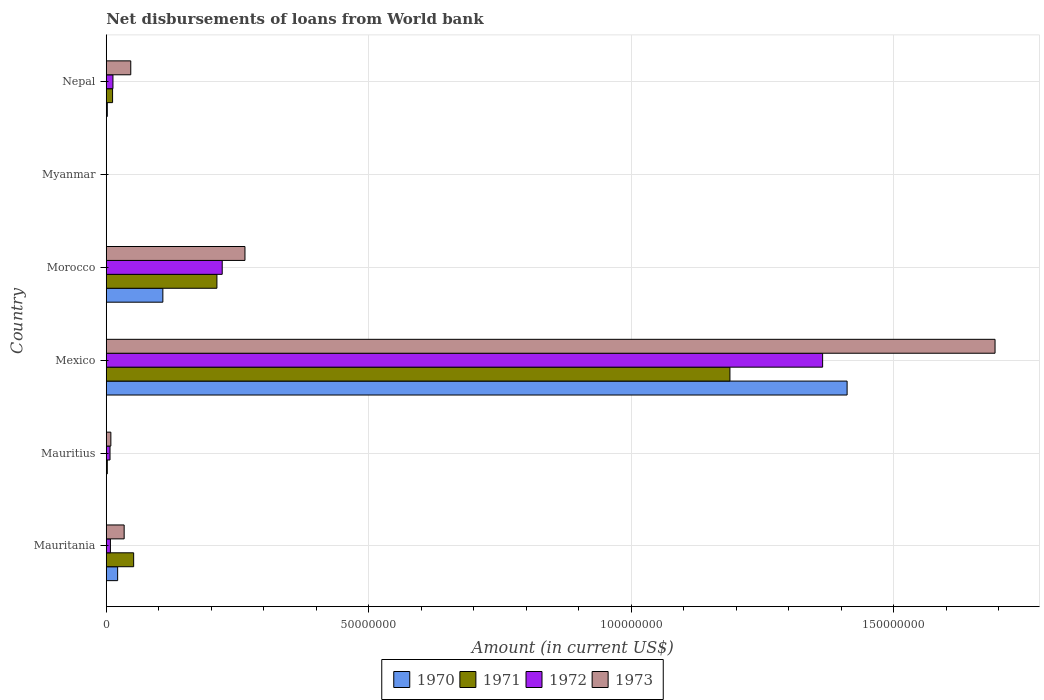Are the number of bars on each tick of the Y-axis equal?
Give a very brief answer. No. How many bars are there on the 4th tick from the top?
Provide a short and direct response. 4. How many bars are there on the 6th tick from the bottom?
Offer a terse response. 4. What is the label of the 4th group of bars from the top?
Offer a terse response. Mexico. What is the amount of loan disbursed from World Bank in 1972 in Myanmar?
Make the answer very short. 0. Across all countries, what is the maximum amount of loan disbursed from World Bank in 1972?
Keep it short and to the point. 1.36e+08. What is the total amount of loan disbursed from World Bank in 1970 in the graph?
Provide a succinct answer. 1.54e+08. What is the difference between the amount of loan disbursed from World Bank in 1970 in Mexico and that in Nepal?
Your answer should be very brief. 1.41e+08. What is the difference between the amount of loan disbursed from World Bank in 1972 in Morocco and the amount of loan disbursed from World Bank in 1970 in Nepal?
Ensure brevity in your answer.  2.19e+07. What is the average amount of loan disbursed from World Bank in 1972 per country?
Provide a succinct answer. 2.69e+07. What is the difference between the amount of loan disbursed from World Bank in 1972 and amount of loan disbursed from World Bank in 1970 in Morocco?
Offer a very short reply. 1.13e+07. What is the ratio of the amount of loan disbursed from World Bank in 1973 in Morocco to that in Nepal?
Offer a terse response. 5.66. Is the amount of loan disbursed from World Bank in 1971 in Mauritius less than that in Morocco?
Make the answer very short. Yes. What is the difference between the highest and the second highest amount of loan disbursed from World Bank in 1971?
Offer a very short reply. 9.77e+07. What is the difference between the highest and the lowest amount of loan disbursed from World Bank in 1973?
Your response must be concise. 1.69e+08. Is it the case that in every country, the sum of the amount of loan disbursed from World Bank in 1970 and amount of loan disbursed from World Bank in 1972 is greater than the amount of loan disbursed from World Bank in 1971?
Give a very brief answer. No. What is the difference between two consecutive major ticks on the X-axis?
Keep it short and to the point. 5.00e+07. Where does the legend appear in the graph?
Offer a very short reply. Bottom center. How many legend labels are there?
Offer a terse response. 4. How are the legend labels stacked?
Make the answer very short. Horizontal. What is the title of the graph?
Provide a succinct answer. Net disbursements of loans from World bank. Does "1991" appear as one of the legend labels in the graph?
Give a very brief answer. No. What is the label or title of the X-axis?
Ensure brevity in your answer.  Amount (in current US$). What is the Amount (in current US$) in 1970 in Mauritania?
Your answer should be compact. 2.17e+06. What is the Amount (in current US$) in 1971 in Mauritania?
Give a very brief answer. 5.22e+06. What is the Amount (in current US$) of 1972 in Mauritania?
Ensure brevity in your answer.  7.93e+05. What is the Amount (in current US$) of 1973 in Mauritania?
Ensure brevity in your answer.  3.41e+06. What is the Amount (in current US$) of 1970 in Mauritius?
Your answer should be very brief. 0. What is the Amount (in current US$) in 1971 in Mauritius?
Provide a short and direct response. 1.99e+05. What is the Amount (in current US$) of 1972 in Mauritius?
Your answer should be compact. 7.17e+05. What is the Amount (in current US$) in 1973 in Mauritius?
Provide a succinct answer. 8.79e+05. What is the Amount (in current US$) in 1970 in Mexico?
Provide a succinct answer. 1.41e+08. What is the Amount (in current US$) in 1971 in Mexico?
Keep it short and to the point. 1.19e+08. What is the Amount (in current US$) in 1972 in Mexico?
Your answer should be very brief. 1.36e+08. What is the Amount (in current US$) of 1973 in Mexico?
Offer a terse response. 1.69e+08. What is the Amount (in current US$) in 1970 in Morocco?
Your response must be concise. 1.08e+07. What is the Amount (in current US$) of 1971 in Morocco?
Give a very brief answer. 2.11e+07. What is the Amount (in current US$) of 1972 in Morocco?
Provide a short and direct response. 2.21e+07. What is the Amount (in current US$) in 1973 in Morocco?
Your answer should be compact. 2.64e+07. What is the Amount (in current US$) of 1970 in Myanmar?
Give a very brief answer. 0. What is the Amount (in current US$) in 1971 in Myanmar?
Keep it short and to the point. 0. What is the Amount (in current US$) of 1972 in Myanmar?
Keep it short and to the point. 0. What is the Amount (in current US$) in 1970 in Nepal?
Provide a succinct answer. 2.02e+05. What is the Amount (in current US$) in 1971 in Nepal?
Ensure brevity in your answer.  1.21e+06. What is the Amount (in current US$) of 1972 in Nepal?
Your answer should be compact. 1.28e+06. What is the Amount (in current US$) in 1973 in Nepal?
Your answer should be very brief. 4.67e+06. Across all countries, what is the maximum Amount (in current US$) of 1970?
Make the answer very short. 1.41e+08. Across all countries, what is the maximum Amount (in current US$) of 1971?
Give a very brief answer. 1.19e+08. Across all countries, what is the maximum Amount (in current US$) in 1972?
Your answer should be compact. 1.36e+08. Across all countries, what is the maximum Amount (in current US$) in 1973?
Give a very brief answer. 1.69e+08. Across all countries, what is the minimum Amount (in current US$) in 1971?
Your answer should be compact. 0. Across all countries, what is the minimum Amount (in current US$) in 1972?
Your answer should be very brief. 0. Across all countries, what is the minimum Amount (in current US$) of 1973?
Offer a very short reply. 0. What is the total Amount (in current US$) of 1970 in the graph?
Make the answer very short. 1.54e+08. What is the total Amount (in current US$) of 1971 in the graph?
Your response must be concise. 1.46e+08. What is the total Amount (in current US$) of 1972 in the graph?
Keep it short and to the point. 1.61e+08. What is the total Amount (in current US$) of 1973 in the graph?
Give a very brief answer. 2.05e+08. What is the difference between the Amount (in current US$) of 1971 in Mauritania and that in Mauritius?
Your answer should be compact. 5.02e+06. What is the difference between the Amount (in current US$) of 1972 in Mauritania and that in Mauritius?
Ensure brevity in your answer.  7.60e+04. What is the difference between the Amount (in current US$) in 1973 in Mauritania and that in Mauritius?
Provide a succinct answer. 2.53e+06. What is the difference between the Amount (in current US$) of 1970 in Mauritania and that in Mexico?
Your answer should be very brief. -1.39e+08. What is the difference between the Amount (in current US$) in 1971 in Mauritania and that in Mexico?
Provide a succinct answer. -1.14e+08. What is the difference between the Amount (in current US$) of 1972 in Mauritania and that in Mexico?
Make the answer very short. -1.36e+08. What is the difference between the Amount (in current US$) of 1973 in Mauritania and that in Mexico?
Provide a succinct answer. -1.66e+08. What is the difference between the Amount (in current US$) of 1970 in Mauritania and that in Morocco?
Keep it short and to the point. -8.61e+06. What is the difference between the Amount (in current US$) of 1971 in Mauritania and that in Morocco?
Provide a short and direct response. -1.59e+07. What is the difference between the Amount (in current US$) in 1972 in Mauritania and that in Morocco?
Your answer should be compact. -2.13e+07. What is the difference between the Amount (in current US$) in 1973 in Mauritania and that in Morocco?
Ensure brevity in your answer.  -2.30e+07. What is the difference between the Amount (in current US$) of 1970 in Mauritania and that in Nepal?
Make the answer very short. 1.97e+06. What is the difference between the Amount (in current US$) of 1971 in Mauritania and that in Nepal?
Offer a terse response. 4.01e+06. What is the difference between the Amount (in current US$) in 1972 in Mauritania and that in Nepal?
Keep it short and to the point. -4.84e+05. What is the difference between the Amount (in current US$) in 1973 in Mauritania and that in Nepal?
Offer a very short reply. -1.26e+06. What is the difference between the Amount (in current US$) of 1971 in Mauritius and that in Mexico?
Offer a terse response. -1.19e+08. What is the difference between the Amount (in current US$) in 1972 in Mauritius and that in Mexico?
Ensure brevity in your answer.  -1.36e+08. What is the difference between the Amount (in current US$) in 1973 in Mauritius and that in Mexico?
Provide a short and direct response. -1.68e+08. What is the difference between the Amount (in current US$) in 1971 in Mauritius and that in Morocco?
Ensure brevity in your answer.  -2.09e+07. What is the difference between the Amount (in current US$) in 1972 in Mauritius and that in Morocco?
Your answer should be very brief. -2.14e+07. What is the difference between the Amount (in current US$) in 1973 in Mauritius and that in Morocco?
Your response must be concise. -2.55e+07. What is the difference between the Amount (in current US$) in 1971 in Mauritius and that in Nepal?
Offer a very short reply. -1.01e+06. What is the difference between the Amount (in current US$) of 1972 in Mauritius and that in Nepal?
Ensure brevity in your answer.  -5.60e+05. What is the difference between the Amount (in current US$) in 1973 in Mauritius and that in Nepal?
Keep it short and to the point. -3.79e+06. What is the difference between the Amount (in current US$) of 1970 in Mexico and that in Morocco?
Your answer should be compact. 1.30e+08. What is the difference between the Amount (in current US$) in 1971 in Mexico and that in Morocco?
Give a very brief answer. 9.77e+07. What is the difference between the Amount (in current US$) of 1972 in Mexico and that in Morocco?
Your response must be concise. 1.14e+08. What is the difference between the Amount (in current US$) of 1973 in Mexico and that in Morocco?
Make the answer very short. 1.43e+08. What is the difference between the Amount (in current US$) of 1970 in Mexico and that in Nepal?
Provide a succinct answer. 1.41e+08. What is the difference between the Amount (in current US$) of 1971 in Mexico and that in Nepal?
Offer a terse response. 1.18e+08. What is the difference between the Amount (in current US$) of 1972 in Mexico and that in Nepal?
Keep it short and to the point. 1.35e+08. What is the difference between the Amount (in current US$) in 1973 in Mexico and that in Nepal?
Ensure brevity in your answer.  1.65e+08. What is the difference between the Amount (in current US$) in 1970 in Morocco and that in Nepal?
Offer a very short reply. 1.06e+07. What is the difference between the Amount (in current US$) of 1971 in Morocco and that in Nepal?
Offer a terse response. 1.99e+07. What is the difference between the Amount (in current US$) in 1972 in Morocco and that in Nepal?
Your answer should be very brief. 2.08e+07. What is the difference between the Amount (in current US$) in 1973 in Morocco and that in Nepal?
Provide a succinct answer. 2.18e+07. What is the difference between the Amount (in current US$) of 1970 in Mauritania and the Amount (in current US$) of 1971 in Mauritius?
Provide a short and direct response. 1.97e+06. What is the difference between the Amount (in current US$) of 1970 in Mauritania and the Amount (in current US$) of 1972 in Mauritius?
Offer a terse response. 1.45e+06. What is the difference between the Amount (in current US$) of 1970 in Mauritania and the Amount (in current US$) of 1973 in Mauritius?
Your response must be concise. 1.29e+06. What is the difference between the Amount (in current US$) of 1971 in Mauritania and the Amount (in current US$) of 1972 in Mauritius?
Your answer should be very brief. 4.50e+06. What is the difference between the Amount (in current US$) of 1971 in Mauritania and the Amount (in current US$) of 1973 in Mauritius?
Offer a terse response. 4.34e+06. What is the difference between the Amount (in current US$) in 1972 in Mauritania and the Amount (in current US$) in 1973 in Mauritius?
Keep it short and to the point. -8.60e+04. What is the difference between the Amount (in current US$) in 1970 in Mauritania and the Amount (in current US$) in 1971 in Mexico?
Provide a short and direct response. -1.17e+08. What is the difference between the Amount (in current US$) in 1970 in Mauritania and the Amount (in current US$) in 1972 in Mexico?
Provide a short and direct response. -1.34e+08. What is the difference between the Amount (in current US$) in 1970 in Mauritania and the Amount (in current US$) in 1973 in Mexico?
Ensure brevity in your answer.  -1.67e+08. What is the difference between the Amount (in current US$) in 1971 in Mauritania and the Amount (in current US$) in 1972 in Mexico?
Provide a short and direct response. -1.31e+08. What is the difference between the Amount (in current US$) in 1971 in Mauritania and the Amount (in current US$) in 1973 in Mexico?
Your answer should be compact. -1.64e+08. What is the difference between the Amount (in current US$) in 1972 in Mauritania and the Amount (in current US$) in 1973 in Mexico?
Your answer should be very brief. -1.68e+08. What is the difference between the Amount (in current US$) in 1970 in Mauritania and the Amount (in current US$) in 1971 in Morocco?
Ensure brevity in your answer.  -1.89e+07. What is the difference between the Amount (in current US$) in 1970 in Mauritania and the Amount (in current US$) in 1972 in Morocco?
Keep it short and to the point. -1.99e+07. What is the difference between the Amount (in current US$) in 1970 in Mauritania and the Amount (in current US$) in 1973 in Morocco?
Give a very brief answer. -2.43e+07. What is the difference between the Amount (in current US$) of 1971 in Mauritania and the Amount (in current US$) of 1972 in Morocco?
Provide a succinct answer. -1.69e+07. What is the difference between the Amount (in current US$) of 1971 in Mauritania and the Amount (in current US$) of 1973 in Morocco?
Offer a terse response. -2.12e+07. What is the difference between the Amount (in current US$) of 1972 in Mauritania and the Amount (in current US$) of 1973 in Morocco?
Ensure brevity in your answer.  -2.56e+07. What is the difference between the Amount (in current US$) of 1970 in Mauritania and the Amount (in current US$) of 1971 in Nepal?
Give a very brief answer. 9.63e+05. What is the difference between the Amount (in current US$) of 1970 in Mauritania and the Amount (in current US$) of 1972 in Nepal?
Keep it short and to the point. 8.93e+05. What is the difference between the Amount (in current US$) in 1970 in Mauritania and the Amount (in current US$) in 1973 in Nepal?
Provide a succinct answer. -2.50e+06. What is the difference between the Amount (in current US$) in 1971 in Mauritania and the Amount (in current US$) in 1972 in Nepal?
Provide a short and direct response. 3.94e+06. What is the difference between the Amount (in current US$) in 1971 in Mauritania and the Amount (in current US$) in 1973 in Nepal?
Provide a succinct answer. 5.52e+05. What is the difference between the Amount (in current US$) in 1972 in Mauritania and the Amount (in current US$) in 1973 in Nepal?
Your response must be concise. -3.88e+06. What is the difference between the Amount (in current US$) of 1971 in Mauritius and the Amount (in current US$) of 1972 in Mexico?
Your answer should be very brief. -1.36e+08. What is the difference between the Amount (in current US$) in 1971 in Mauritius and the Amount (in current US$) in 1973 in Mexico?
Your response must be concise. -1.69e+08. What is the difference between the Amount (in current US$) of 1972 in Mauritius and the Amount (in current US$) of 1973 in Mexico?
Offer a terse response. -1.69e+08. What is the difference between the Amount (in current US$) in 1971 in Mauritius and the Amount (in current US$) in 1972 in Morocco?
Provide a short and direct response. -2.19e+07. What is the difference between the Amount (in current US$) of 1971 in Mauritius and the Amount (in current US$) of 1973 in Morocco?
Give a very brief answer. -2.62e+07. What is the difference between the Amount (in current US$) in 1972 in Mauritius and the Amount (in current US$) in 1973 in Morocco?
Give a very brief answer. -2.57e+07. What is the difference between the Amount (in current US$) in 1971 in Mauritius and the Amount (in current US$) in 1972 in Nepal?
Offer a very short reply. -1.08e+06. What is the difference between the Amount (in current US$) of 1971 in Mauritius and the Amount (in current US$) of 1973 in Nepal?
Offer a very short reply. -4.47e+06. What is the difference between the Amount (in current US$) in 1972 in Mauritius and the Amount (in current US$) in 1973 in Nepal?
Give a very brief answer. -3.95e+06. What is the difference between the Amount (in current US$) of 1970 in Mexico and the Amount (in current US$) of 1971 in Morocco?
Your answer should be compact. 1.20e+08. What is the difference between the Amount (in current US$) of 1970 in Mexico and the Amount (in current US$) of 1972 in Morocco?
Provide a short and direct response. 1.19e+08. What is the difference between the Amount (in current US$) of 1970 in Mexico and the Amount (in current US$) of 1973 in Morocco?
Your answer should be very brief. 1.15e+08. What is the difference between the Amount (in current US$) of 1971 in Mexico and the Amount (in current US$) of 1972 in Morocco?
Your answer should be compact. 9.67e+07. What is the difference between the Amount (in current US$) in 1971 in Mexico and the Amount (in current US$) in 1973 in Morocco?
Your answer should be compact. 9.24e+07. What is the difference between the Amount (in current US$) of 1972 in Mexico and the Amount (in current US$) of 1973 in Morocco?
Your answer should be very brief. 1.10e+08. What is the difference between the Amount (in current US$) of 1970 in Mexico and the Amount (in current US$) of 1971 in Nepal?
Ensure brevity in your answer.  1.40e+08. What is the difference between the Amount (in current US$) of 1970 in Mexico and the Amount (in current US$) of 1972 in Nepal?
Make the answer very short. 1.40e+08. What is the difference between the Amount (in current US$) in 1970 in Mexico and the Amount (in current US$) in 1973 in Nepal?
Provide a succinct answer. 1.36e+08. What is the difference between the Amount (in current US$) in 1971 in Mexico and the Amount (in current US$) in 1972 in Nepal?
Provide a succinct answer. 1.18e+08. What is the difference between the Amount (in current US$) in 1971 in Mexico and the Amount (in current US$) in 1973 in Nepal?
Your answer should be very brief. 1.14e+08. What is the difference between the Amount (in current US$) of 1972 in Mexico and the Amount (in current US$) of 1973 in Nepal?
Ensure brevity in your answer.  1.32e+08. What is the difference between the Amount (in current US$) of 1970 in Morocco and the Amount (in current US$) of 1971 in Nepal?
Make the answer very short. 9.58e+06. What is the difference between the Amount (in current US$) in 1970 in Morocco and the Amount (in current US$) in 1972 in Nepal?
Ensure brevity in your answer.  9.50e+06. What is the difference between the Amount (in current US$) of 1970 in Morocco and the Amount (in current US$) of 1973 in Nepal?
Give a very brief answer. 6.11e+06. What is the difference between the Amount (in current US$) in 1971 in Morocco and the Amount (in current US$) in 1972 in Nepal?
Provide a short and direct response. 1.98e+07. What is the difference between the Amount (in current US$) in 1971 in Morocco and the Amount (in current US$) in 1973 in Nepal?
Offer a very short reply. 1.64e+07. What is the difference between the Amount (in current US$) in 1972 in Morocco and the Amount (in current US$) in 1973 in Nepal?
Provide a short and direct response. 1.74e+07. What is the average Amount (in current US$) of 1970 per country?
Give a very brief answer. 2.57e+07. What is the average Amount (in current US$) of 1971 per country?
Your response must be concise. 2.44e+07. What is the average Amount (in current US$) of 1972 per country?
Give a very brief answer. 2.69e+07. What is the average Amount (in current US$) in 1973 per country?
Your answer should be compact. 3.41e+07. What is the difference between the Amount (in current US$) in 1970 and Amount (in current US$) in 1971 in Mauritania?
Offer a terse response. -3.05e+06. What is the difference between the Amount (in current US$) in 1970 and Amount (in current US$) in 1972 in Mauritania?
Offer a very short reply. 1.38e+06. What is the difference between the Amount (in current US$) in 1970 and Amount (in current US$) in 1973 in Mauritania?
Offer a very short reply. -1.24e+06. What is the difference between the Amount (in current US$) of 1971 and Amount (in current US$) of 1972 in Mauritania?
Give a very brief answer. 4.43e+06. What is the difference between the Amount (in current US$) in 1971 and Amount (in current US$) in 1973 in Mauritania?
Offer a very short reply. 1.81e+06. What is the difference between the Amount (in current US$) in 1972 and Amount (in current US$) in 1973 in Mauritania?
Your answer should be very brief. -2.62e+06. What is the difference between the Amount (in current US$) of 1971 and Amount (in current US$) of 1972 in Mauritius?
Ensure brevity in your answer.  -5.18e+05. What is the difference between the Amount (in current US$) in 1971 and Amount (in current US$) in 1973 in Mauritius?
Provide a succinct answer. -6.80e+05. What is the difference between the Amount (in current US$) in 1972 and Amount (in current US$) in 1973 in Mauritius?
Give a very brief answer. -1.62e+05. What is the difference between the Amount (in current US$) in 1970 and Amount (in current US$) in 1971 in Mexico?
Provide a short and direct response. 2.23e+07. What is the difference between the Amount (in current US$) in 1970 and Amount (in current US$) in 1972 in Mexico?
Provide a succinct answer. 4.66e+06. What is the difference between the Amount (in current US$) of 1970 and Amount (in current US$) of 1973 in Mexico?
Your answer should be very brief. -2.82e+07. What is the difference between the Amount (in current US$) in 1971 and Amount (in current US$) in 1972 in Mexico?
Provide a short and direct response. -1.77e+07. What is the difference between the Amount (in current US$) in 1971 and Amount (in current US$) in 1973 in Mexico?
Make the answer very short. -5.05e+07. What is the difference between the Amount (in current US$) of 1972 and Amount (in current US$) of 1973 in Mexico?
Provide a short and direct response. -3.28e+07. What is the difference between the Amount (in current US$) of 1970 and Amount (in current US$) of 1971 in Morocco?
Provide a succinct answer. -1.03e+07. What is the difference between the Amount (in current US$) in 1970 and Amount (in current US$) in 1972 in Morocco?
Your answer should be very brief. -1.13e+07. What is the difference between the Amount (in current US$) of 1970 and Amount (in current US$) of 1973 in Morocco?
Ensure brevity in your answer.  -1.56e+07. What is the difference between the Amount (in current US$) in 1971 and Amount (in current US$) in 1972 in Morocco?
Offer a very short reply. -1.01e+06. What is the difference between the Amount (in current US$) in 1971 and Amount (in current US$) in 1973 in Morocco?
Provide a succinct answer. -5.34e+06. What is the difference between the Amount (in current US$) in 1972 and Amount (in current US$) in 1973 in Morocco?
Your answer should be compact. -4.33e+06. What is the difference between the Amount (in current US$) in 1970 and Amount (in current US$) in 1971 in Nepal?
Keep it short and to the point. -1.00e+06. What is the difference between the Amount (in current US$) of 1970 and Amount (in current US$) of 1972 in Nepal?
Make the answer very short. -1.08e+06. What is the difference between the Amount (in current US$) of 1970 and Amount (in current US$) of 1973 in Nepal?
Keep it short and to the point. -4.47e+06. What is the difference between the Amount (in current US$) in 1971 and Amount (in current US$) in 1972 in Nepal?
Ensure brevity in your answer.  -7.00e+04. What is the difference between the Amount (in current US$) of 1971 and Amount (in current US$) of 1973 in Nepal?
Provide a short and direct response. -3.46e+06. What is the difference between the Amount (in current US$) of 1972 and Amount (in current US$) of 1973 in Nepal?
Your answer should be very brief. -3.39e+06. What is the ratio of the Amount (in current US$) in 1971 in Mauritania to that in Mauritius?
Offer a very short reply. 26.24. What is the ratio of the Amount (in current US$) of 1972 in Mauritania to that in Mauritius?
Offer a very short reply. 1.11. What is the ratio of the Amount (in current US$) of 1973 in Mauritania to that in Mauritius?
Your answer should be very brief. 3.88. What is the ratio of the Amount (in current US$) in 1970 in Mauritania to that in Mexico?
Make the answer very short. 0.02. What is the ratio of the Amount (in current US$) of 1971 in Mauritania to that in Mexico?
Provide a succinct answer. 0.04. What is the ratio of the Amount (in current US$) in 1972 in Mauritania to that in Mexico?
Give a very brief answer. 0.01. What is the ratio of the Amount (in current US$) of 1973 in Mauritania to that in Mexico?
Keep it short and to the point. 0.02. What is the ratio of the Amount (in current US$) in 1970 in Mauritania to that in Morocco?
Your answer should be compact. 0.2. What is the ratio of the Amount (in current US$) in 1971 in Mauritania to that in Morocco?
Ensure brevity in your answer.  0.25. What is the ratio of the Amount (in current US$) in 1972 in Mauritania to that in Morocco?
Your answer should be very brief. 0.04. What is the ratio of the Amount (in current US$) in 1973 in Mauritania to that in Morocco?
Offer a very short reply. 0.13. What is the ratio of the Amount (in current US$) in 1970 in Mauritania to that in Nepal?
Give a very brief answer. 10.74. What is the ratio of the Amount (in current US$) of 1971 in Mauritania to that in Nepal?
Keep it short and to the point. 4.33. What is the ratio of the Amount (in current US$) of 1972 in Mauritania to that in Nepal?
Your answer should be very brief. 0.62. What is the ratio of the Amount (in current US$) in 1973 in Mauritania to that in Nepal?
Your answer should be compact. 0.73. What is the ratio of the Amount (in current US$) in 1971 in Mauritius to that in Mexico?
Provide a short and direct response. 0. What is the ratio of the Amount (in current US$) in 1972 in Mauritius to that in Mexico?
Make the answer very short. 0.01. What is the ratio of the Amount (in current US$) of 1973 in Mauritius to that in Mexico?
Offer a terse response. 0.01. What is the ratio of the Amount (in current US$) of 1971 in Mauritius to that in Morocco?
Your answer should be compact. 0.01. What is the ratio of the Amount (in current US$) in 1972 in Mauritius to that in Morocco?
Your answer should be compact. 0.03. What is the ratio of the Amount (in current US$) of 1971 in Mauritius to that in Nepal?
Give a very brief answer. 0.16. What is the ratio of the Amount (in current US$) in 1972 in Mauritius to that in Nepal?
Make the answer very short. 0.56. What is the ratio of the Amount (in current US$) in 1973 in Mauritius to that in Nepal?
Offer a very short reply. 0.19. What is the ratio of the Amount (in current US$) of 1970 in Mexico to that in Morocco?
Make the answer very short. 13.09. What is the ratio of the Amount (in current US$) in 1971 in Mexico to that in Morocco?
Your answer should be compact. 5.63. What is the ratio of the Amount (in current US$) in 1972 in Mexico to that in Morocco?
Ensure brevity in your answer.  6.18. What is the ratio of the Amount (in current US$) in 1973 in Mexico to that in Morocco?
Keep it short and to the point. 6.41. What is the ratio of the Amount (in current US$) of 1970 in Mexico to that in Nepal?
Provide a succinct answer. 698.56. What is the ratio of the Amount (in current US$) of 1971 in Mexico to that in Nepal?
Provide a short and direct response. 98.42. What is the ratio of the Amount (in current US$) of 1972 in Mexico to that in Nepal?
Your answer should be very brief. 106.85. What is the ratio of the Amount (in current US$) in 1973 in Mexico to that in Nepal?
Provide a short and direct response. 36.26. What is the ratio of the Amount (in current US$) of 1970 in Morocco to that in Nepal?
Your answer should be compact. 53.38. What is the ratio of the Amount (in current US$) in 1971 in Morocco to that in Nepal?
Provide a succinct answer. 17.47. What is the ratio of the Amount (in current US$) of 1972 in Morocco to that in Nepal?
Provide a succinct answer. 17.3. What is the ratio of the Amount (in current US$) of 1973 in Morocco to that in Nepal?
Provide a short and direct response. 5.66. What is the difference between the highest and the second highest Amount (in current US$) in 1970?
Your response must be concise. 1.30e+08. What is the difference between the highest and the second highest Amount (in current US$) in 1971?
Give a very brief answer. 9.77e+07. What is the difference between the highest and the second highest Amount (in current US$) of 1972?
Provide a short and direct response. 1.14e+08. What is the difference between the highest and the second highest Amount (in current US$) of 1973?
Your answer should be compact. 1.43e+08. What is the difference between the highest and the lowest Amount (in current US$) in 1970?
Ensure brevity in your answer.  1.41e+08. What is the difference between the highest and the lowest Amount (in current US$) of 1971?
Offer a terse response. 1.19e+08. What is the difference between the highest and the lowest Amount (in current US$) of 1972?
Your answer should be compact. 1.36e+08. What is the difference between the highest and the lowest Amount (in current US$) in 1973?
Provide a succinct answer. 1.69e+08. 